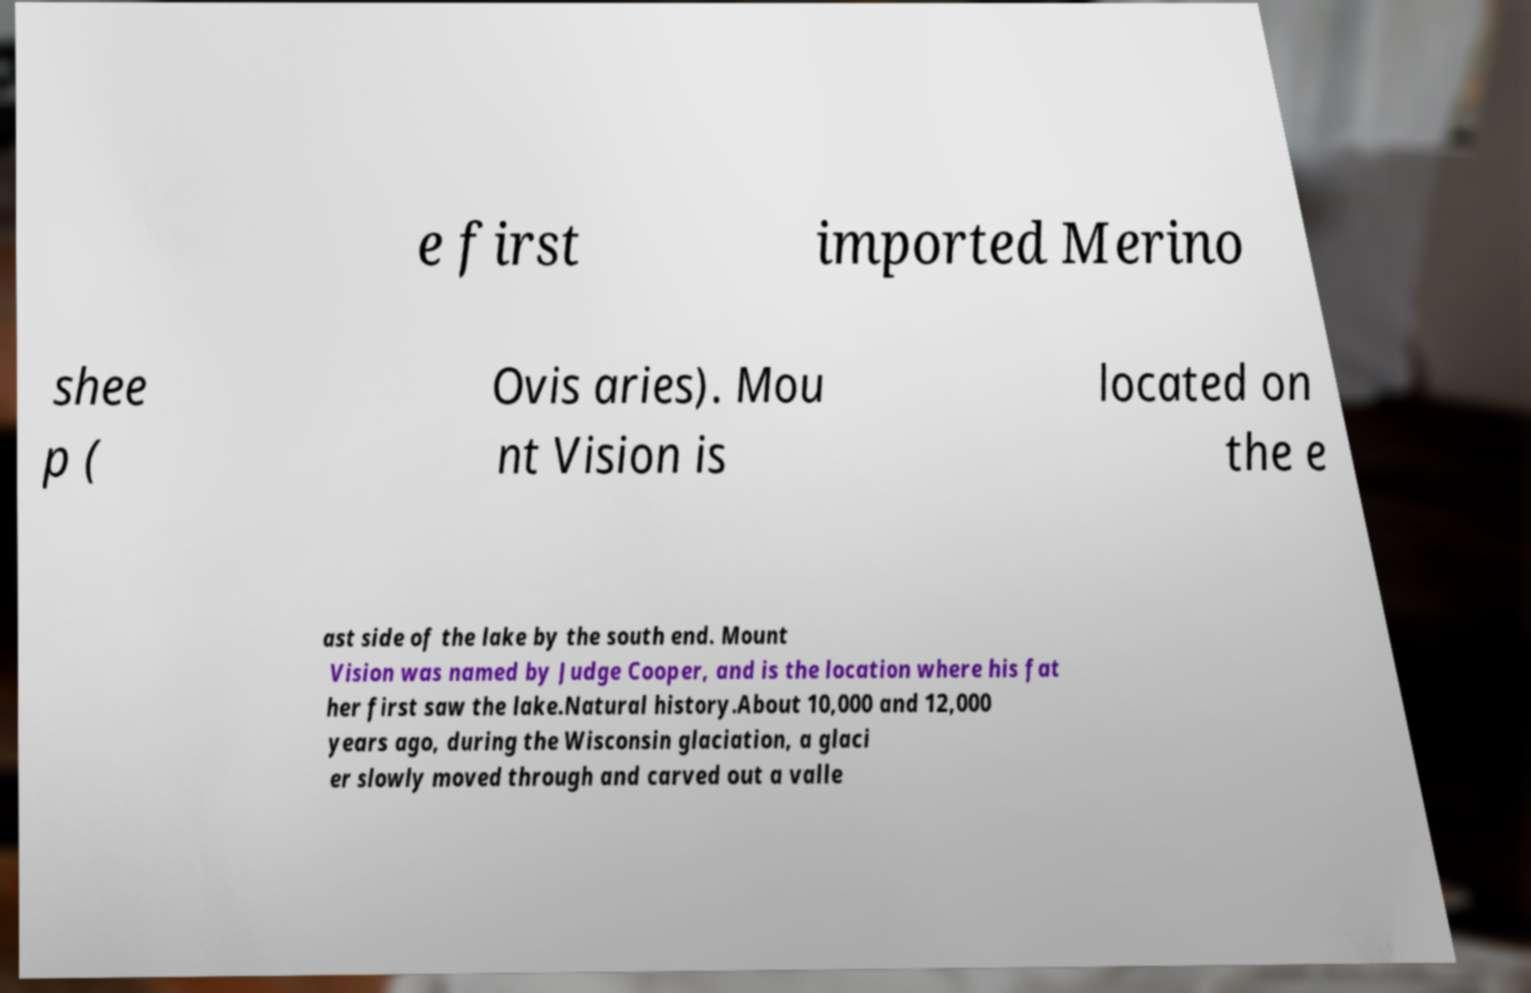For documentation purposes, I need the text within this image transcribed. Could you provide that? e first imported Merino shee p ( Ovis aries). Mou nt Vision is located on the e ast side of the lake by the south end. Mount Vision was named by Judge Cooper, and is the location where his fat her first saw the lake.Natural history.About 10,000 and 12,000 years ago, during the Wisconsin glaciation, a glaci er slowly moved through and carved out a valle 